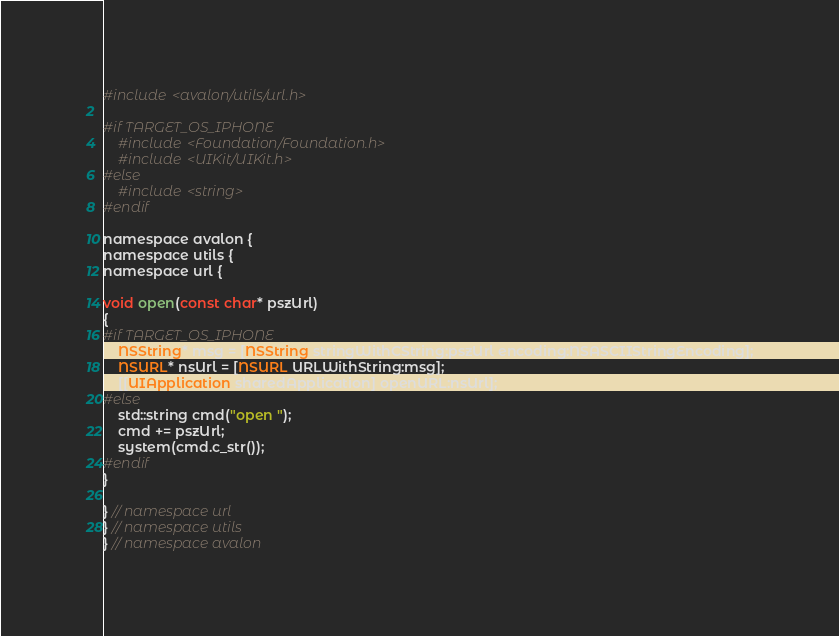<code> <loc_0><loc_0><loc_500><loc_500><_ObjectiveC_>#include <avalon/utils/url.h>

#if TARGET_OS_IPHONE
    #include <Foundation/Foundation.h>
    #include <UIKit/UIKit.h>
#else
    #include <string>
#endif

namespace avalon {
namespace utils {
namespace url {

void open(const char* pszUrl)
{
#if TARGET_OS_IPHONE
    NSString* msg = [NSString stringWithCString:pszUrl encoding:NSASCIIStringEncoding];
    NSURL* nsUrl = [NSURL URLWithString:msg];
    [[UIApplication sharedApplication] openURL:nsUrl];
#else
    std::string cmd("open ");
    cmd += pszUrl;
    system(cmd.c_str());
#endif
}

} // namespace url
} // namespace utils
} // namespace avalon</code> 